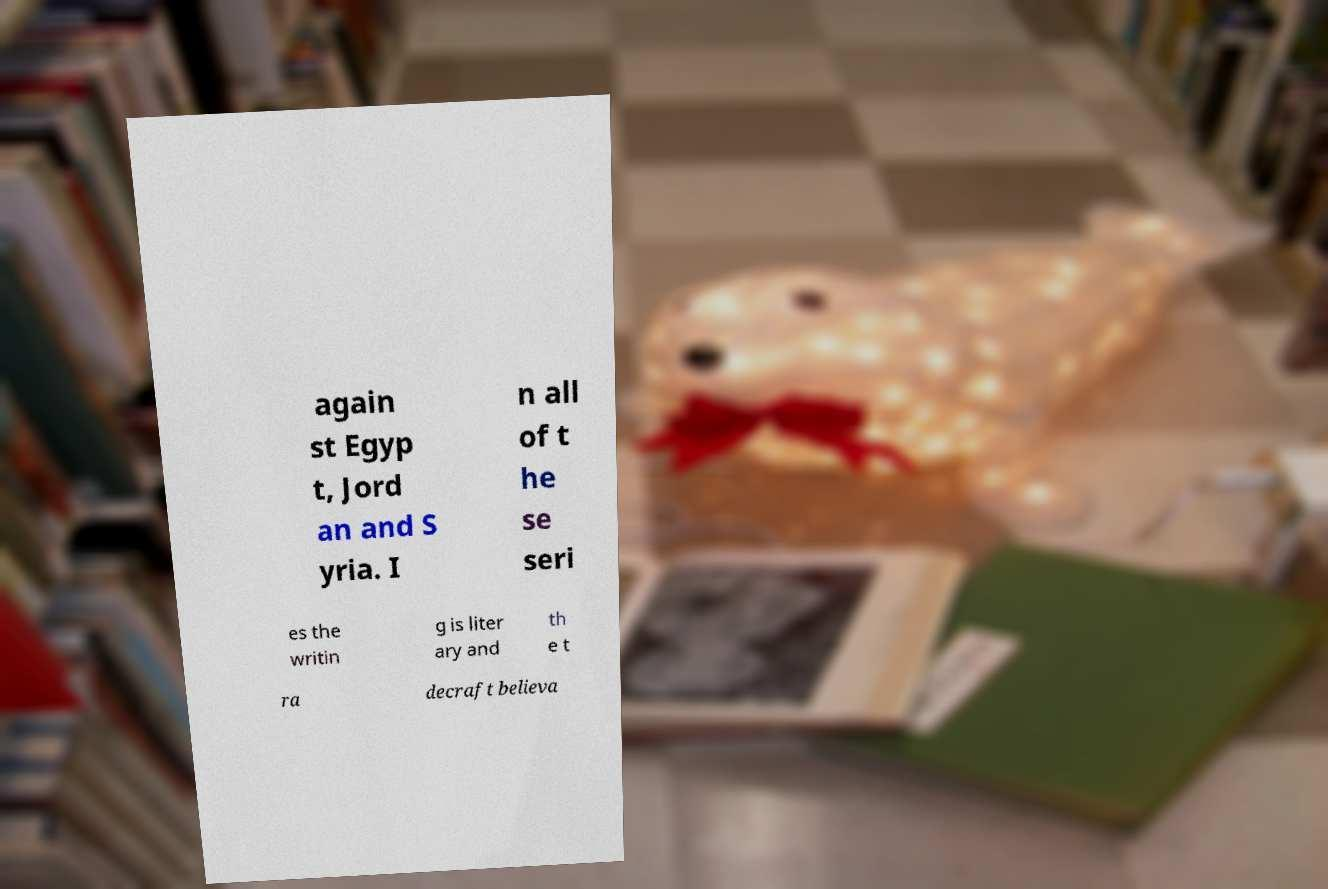Please read and relay the text visible in this image. What does it say? again st Egyp t, Jord an and S yria. I n all of t he se seri es the writin g is liter ary and th e t ra decraft believa 